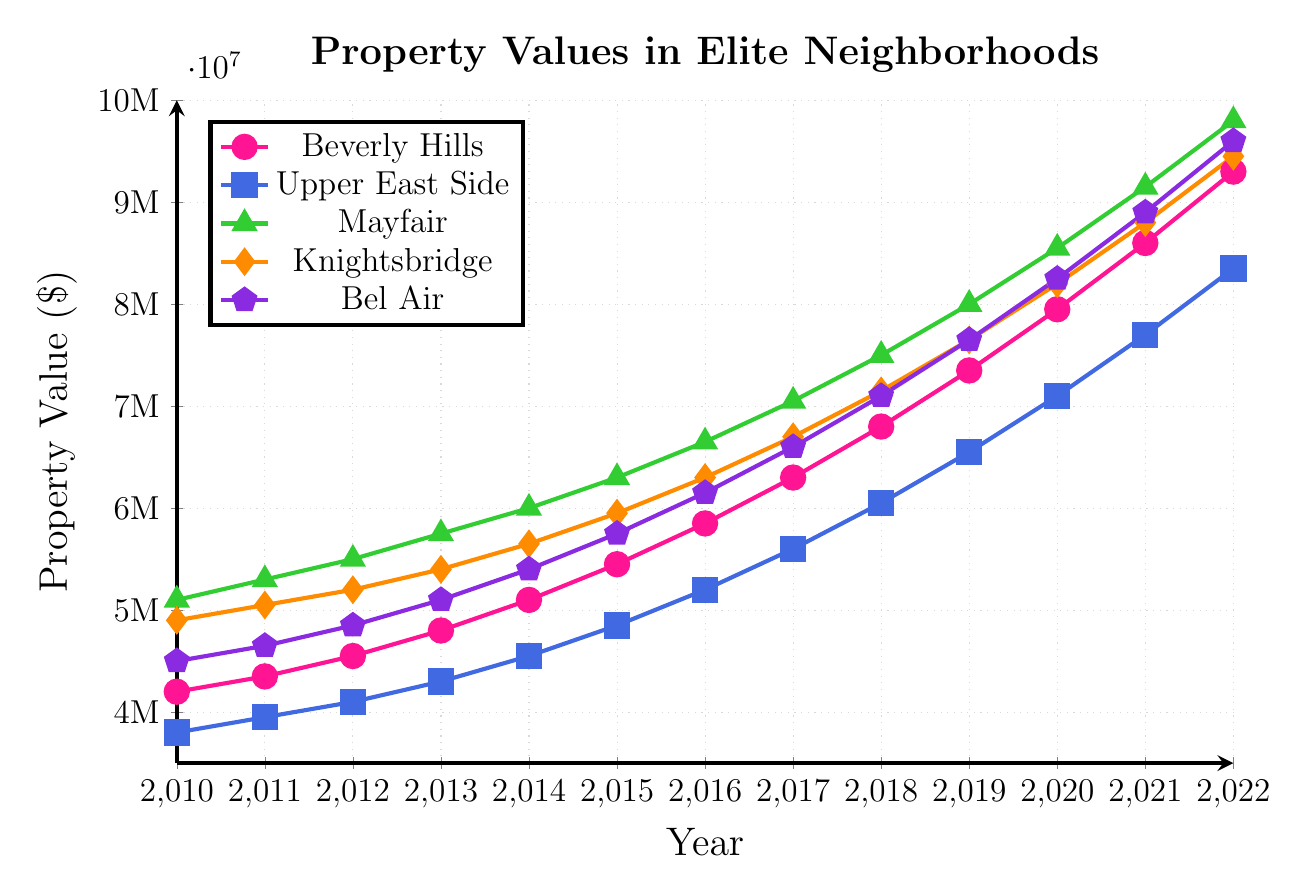What's the trend in property values for Beverly Hills from 2010 to 2022? The line representing Beverly Hills starts at $4.2M in 2010 and consistently rises to $9.3M in 2022. The property values show a steady increase over these years.
Answer: Steady increase Which neighborhood had the highest property value in 2022? The Mayfair line ends the highest on the y-axis in 2022, indicating that Mayfair had the highest property value at $9.8M.
Answer: Mayfair How did property values in Knightsbridge change from 2013 to 2017? In 2013, the property value in Knightsbridge was $5.4M, and it increased to $6.7M in 2017. The value shows a rise from 2013 to 2017 by $1.3M.
Answer: Increased by $1.3M Compare the property values of Upper East Side and Bel Air in 2015. Which one is higher? In 2015, Upper East Side's property value is plotted at $4.85M, and Bel Air's property value is plotted at $5.75M. Bel Air's value is higher.
Answer: Bel Air Calculate the average property value of Mayfair from 2010 to 2012. The values for Mayfair from 2010 to 2012 are $5.1M, $5.3M, and $5.5M. The sum is $15.9M, and dividing by 3 gives an average of $5.3M.
Answer: $5.3M Which neighborhood showed the most significant increase in property values from 2010 to 2022? Subtract 2010 values from 2022 values in each neighborhood: Beverly Hills ($9300K - $4200K = $5100K), Upper East Side ($8350K - $3800K = $4550K), Mayfair ($9800K - $5100K = $4700K), Knightsbridge ($9450K - $4900K = $4550K), Bel Air ($9600K - $4500K = $5100K). Beverly Hills and Bel Air both exhibit the largest increase of $5.1M.
Answer: Beverly Hills and Bel Air Which neighborhood had the least change in property values between 2014 and 2018? Calculate the difference from 2014 to 2018 for each neighborhood: Beverly Hills ($6800K - $5100K = $1700K), Upper East Side ($6050K - $4550K = $1500K), Mayfair ($7500K - $6000K = $1500K), Knightsbridge ($7150K - $5650K = $1500K), Bel Air ($7100K - $5400K = $1700K). Upper East Side, Mayfair, and Knightsbridge show the least change, $1,500,000.
Answer: Upper East Side, Mayfair, and Knightsbridge What is the color representing Knightsbridge in the plot? The color legend indicates that Knightsbridge is represented by an orange line with diamond-shaped markers.
Answer: Orange 